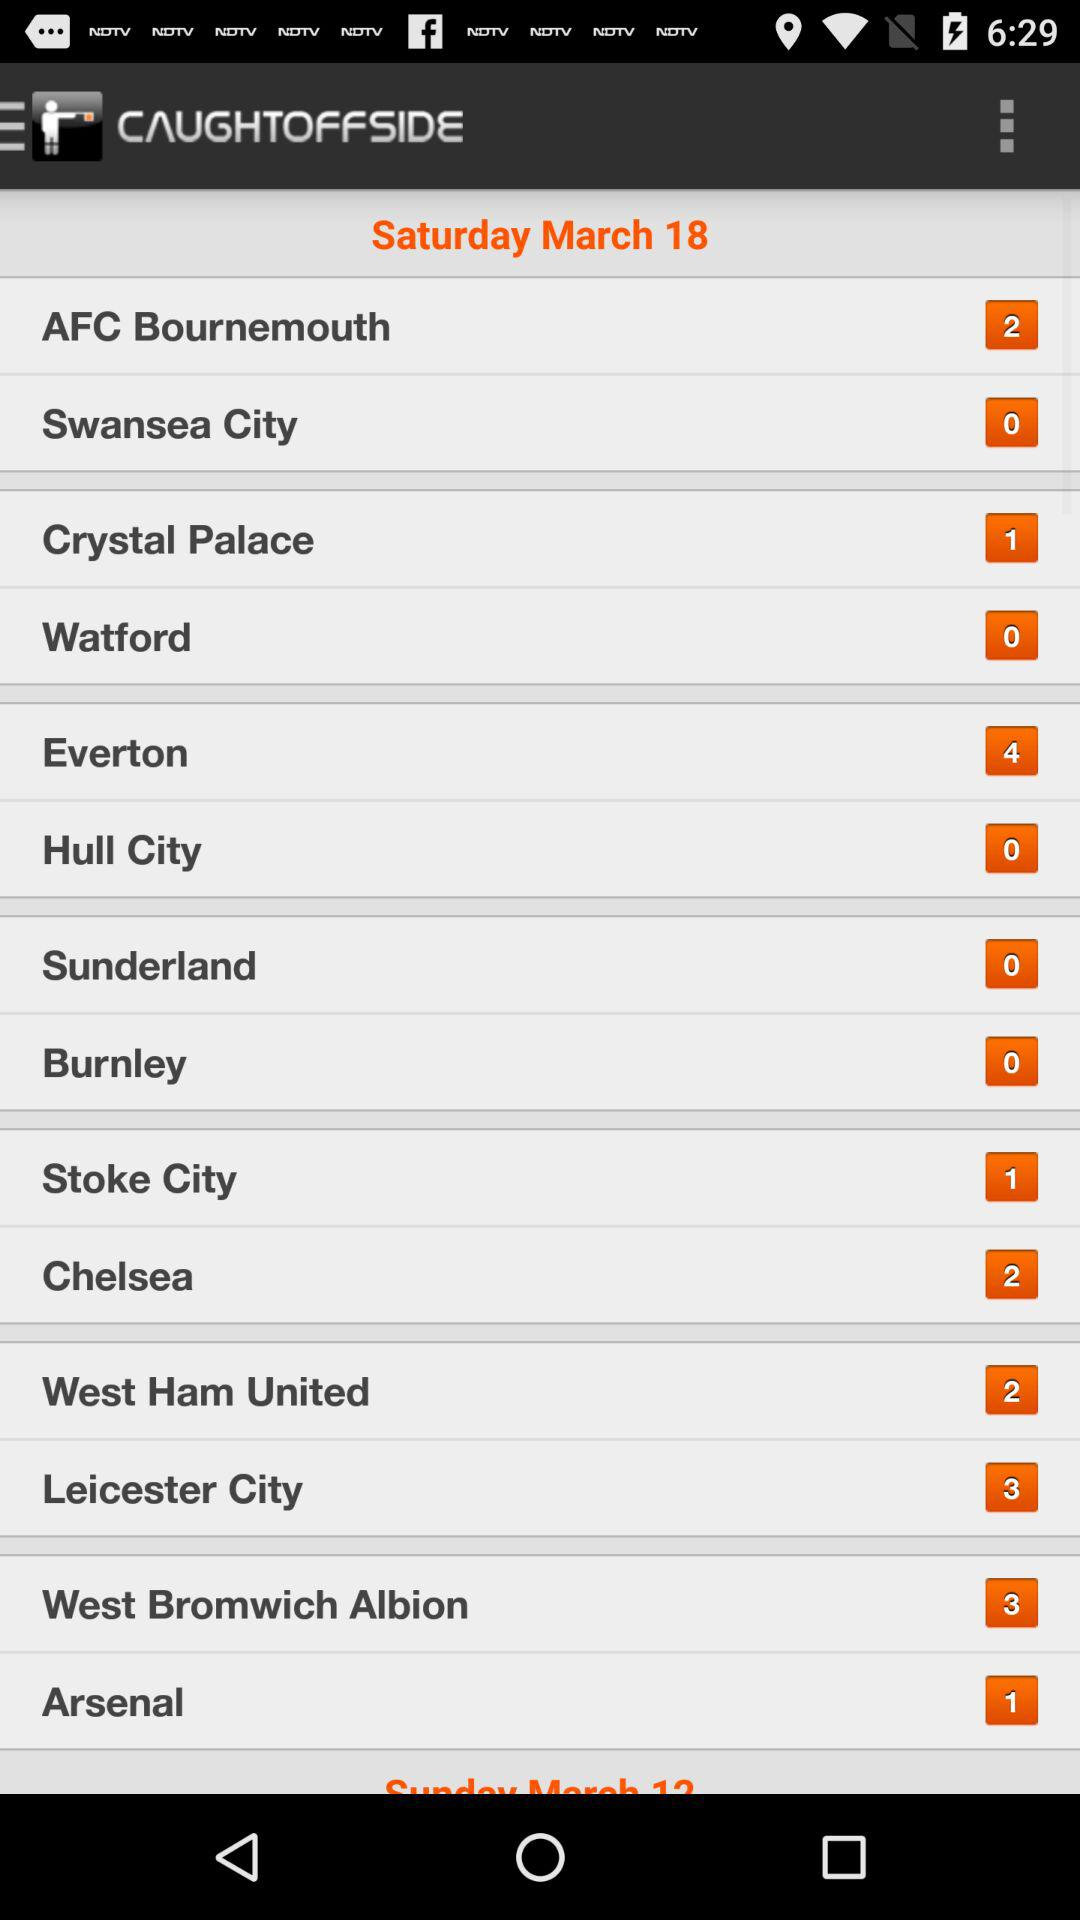How many crystal palaces are there? There is only one crystal palace. 